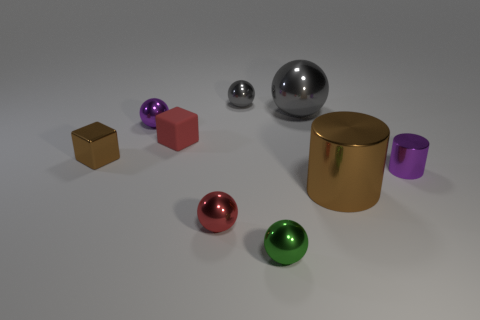What color is the tiny shiny object that is in front of the small shiny block and behind the big brown metal thing? The tiny shiny object situated in front of the small shiny block and behind the big brown metal thing is purple. It has a smooth surface and reflects light, giving it a lustrous appearance. 